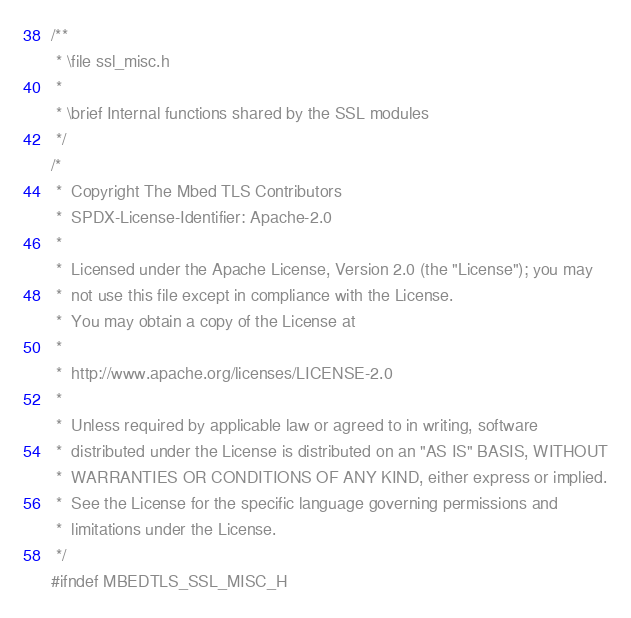<code> <loc_0><loc_0><loc_500><loc_500><_C_>/**
 * \file ssl_misc.h
 *
 * \brief Internal functions shared by the SSL modules
 */
/*
 *  Copyright The Mbed TLS Contributors
 *  SPDX-License-Identifier: Apache-2.0
 *
 *  Licensed under the Apache License, Version 2.0 (the "License"); you may
 *  not use this file except in compliance with the License.
 *  You may obtain a copy of the License at
 *
 *  http://www.apache.org/licenses/LICENSE-2.0
 *
 *  Unless required by applicable law or agreed to in writing, software
 *  distributed under the License is distributed on an "AS IS" BASIS, WITHOUT
 *  WARRANTIES OR CONDITIONS OF ANY KIND, either express or implied.
 *  See the License for the specific language governing permissions and
 *  limitations under the License.
 */
#ifndef MBEDTLS_SSL_MISC_H</code> 